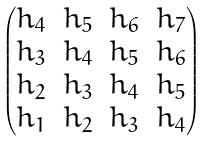<formula> <loc_0><loc_0><loc_500><loc_500>\begin{pmatrix} h _ { 4 } & h _ { 5 } & h _ { 6 } & h _ { 7 } \\ h _ { 3 } & h _ { 4 } & h _ { 5 } & h _ { 6 } \\ h _ { 2 } & h _ { 3 } & h _ { 4 } & h _ { 5 } \\ h _ { 1 } & h _ { 2 } & h _ { 3 } & h _ { 4 } \end{pmatrix}</formula> 